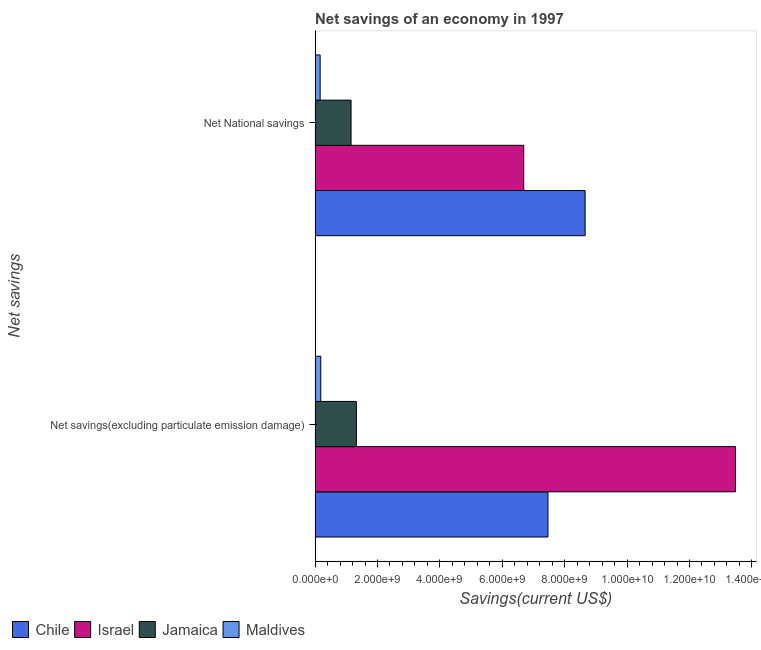How many different coloured bars are there?
Ensure brevity in your answer.  4. Are the number of bars per tick equal to the number of legend labels?
Give a very brief answer. Yes. How many bars are there on the 2nd tick from the bottom?
Offer a very short reply. 4. What is the label of the 1st group of bars from the top?
Give a very brief answer. Net National savings. What is the net savings(excluding particulate emission damage) in Maldives?
Keep it short and to the point. 1.81e+08. Across all countries, what is the maximum net national savings?
Provide a short and direct response. 8.65e+09. Across all countries, what is the minimum net national savings?
Give a very brief answer. 1.62e+08. In which country was the net savings(excluding particulate emission damage) minimum?
Offer a terse response. Maldives. What is the total net national savings in the graph?
Your answer should be compact. 1.67e+1. What is the difference between the net national savings in Jamaica and that in Israel?
Provide a succinct answer. -5.53e+09. What is the difference between the net national savings in Jamaica and the net savings(excluding particulate emission damage) in Chile?
Your response must be concise. -6.31e+09. What is the average net national savings per country?
Make the answer very short. 4.16e+09. What is the difference between the net national savings and net savings(excluding particulate emission damage) in Israel?
Offer a terse response. -6.79e+09. In how many countries, is the net national savings greater than 7600000000 US$?
Your answer should be very brief. 1. What is the ratio of the net savings(excluding particulate emission damage) in Jamaica to that in Israel?
Your answer should be very brief. 0.1. Is the net national savings in Jamaica less than that in Israel?
Your response must be concise. Yes. In how many countries, is the net savings(excluding particulate emission damage) greater than the average net savings(excluding particulate emission damage) taken over all countries?
Make the answer very short. 2. What does the 4th bar from the top in Net National savings represents?
Provide a succinct answer. Chile. How many bars are there?
Your response must be concise. 8. Are all the bars in the graph horizontal?
Your answer should be very brief. Yes. How many countries are there in the graph?
Keep it short and to the point. 4. What is the difference between two consecutive major ticks on the X-axis?
Offer a terse response. 2.00e+09. Are the values on the major ticks of X-axis written in scientific E-notation?
Your answer should be compact. Yes. Does the graph contain any zero values?
Provide a short and direct response. No. Does the graph contain grids?
Your answer should be compact. No. How many legend labels are there?
Give a very brief answer. 4. What is the title of the graph?
Your response must be concise. Net savings of an economy in 1997. What is the label or title of the X-axis?
Offer a terse response. Savings(current US$). What is the label or title of the Y-axis?
Your answer should be compact. Net savings. What is the Savings(current US$) of Chile in Net savings(excluding particulate emission damage)?
Ensure brevity in your answer.  7.46e+09. What is the Savings(current US$) in Israel in Net savings(excluding particulate emission damage)?
Make the answer very short. 1.35e+1. What is the Savings(current US$) of Jamaica in Net savings(excluding particulate emission damage)?
Make the answer very short. 1.32e+09. What is the Savings(current US$) in Maldives in Net savings(excluding particulate emission damage)?
Provide a short and direct response. 1.81e+08. What is the Savings(current US$) of Chile in Net National savings?
Provide a short and direct response. 8.65e+09. What is the Savings(current US$) in Israel in Net National savings?
Offer a terse response. 6.69e+09. What is the Savings(current US$) in Jamaica in Net National savings?
Your response must be concise. 1.15e+09. What is the Savings(current US$) in Maldives in Net National savings?
Ensure brevity in your answer.  1.62e+08. Across all Net savings, what is the maximum Savings(current US$) of Chile?
Provide a succinct answer. 8.65e+09. Across all Net savings, what is the maximum Savings(current US$) in Israel?
Make the answer very short. 1.35e+1. Across all Net savings, what is the maximum Savings(current US$) in Jamaica?
Your response must be concise. 1.32e+09. Across all Net savings, what is the maximum Savings(current US$) in Maldives?
Your response must be concise. 1.81e+08. Across all Net savings, what is the minimum Savings(current US$) in Chile?
Make the answer very short. 7.46e+09. Across all Net savings, what is the minimum Savings(current US$) in Israel?
Keep it short and to the point. 6.69e+09. Across all Net savings, what is the minimum Savings(current US$) of Jamaica?
Make the answer very short. 1.15e+09. Across all Net savings, what is the minimum Savings(current US$) in Maldives?
Your answer should be compact. 1.62e+08. What is the total Savings(current US$) of Chile in the graph?
Provide a succinct answer. 1.61e+1. What is the total Savings(current US$) of Israel in the graph?
Provide a succinct answer. 2.02e+1. What is the total Savings(current US$) of Jamaica in the graph?
Give a very brief answer. 2.47e+09. What is the total Savings(current US$) of Maldives in the graph?
Your answer should be compact. 3.43e+08. What is the difference between the Savings(current US$) in Chile in Net savings(excluding particulate emission damage) and that in Net National savings?
Offer a very short reply. -1.19e+09. What is the difference between the Savings(current US$) in Israel in Net savings(excluding particulate emission damage) and that in Net National savings?
Give a very brief answer. 6.79e+09. What is the difference between the Savings(current US$) of Jamaica in Net savings(excluding particulate emission damage) and that in Net National savings?
Ensure brevity in your answer.  1.70e+08. What is the difference between the Savings(current US$) in Maldives in Net savings(excluding particulate emission damage) and that in Net National savings?
Your response must be concise. 1.97e+07. What is the difference between the Savings(current US$) of Chile in Net savings(excluding particulate emission damage) and the Savings(current US$) of Israel in Net National savings?
Offer a terse response. 7.76e+08. What is the difference between the Savings(current US$) of Chile in Net savings(excluding particulate emission damage) and the Savings(current US$) of Jamaica in Net National savings?
Your answer should be compact. 6.31e+09. What is the difference between the Savings(current US$) of Chile in Net savings(excluding particulate emission damage) and the Savings(current US$) of Maldives in Net National savings?
Your answer should be very brief. 7.30e+09. What is the difference between the Savings(current US$) of Israel in Net savings(excluding particulate emission damage) and the Savings(current US$) of Jamaica in Net National savings?
Keep it short and to the point. 1.23e+1. What is the difference between the Savings(current US$) of Israel in Net savings(excluding particulate emission damage) and the Savings(current US$) of Maldives in Net National savings?
Your answer should be very brief. 1.33e+1. What is the difference between the Savings(current US$) of Jamaica in Net savings(excluding particulate emission damage) and the Savings(current US$) of Maldives in Net National savings?
Provide a succinct answer. 1.16e+09. What is the average Savings(current US$) of Chile per Net savings?
Make the answer very short. 8.06e+09. What is the average Savings(current US$) in Israel per Net savings?
Provide a succinct answer. 1.01e+1. What is the average Savings(current US$) in Jamaica per Net savings?
Offer a very short reply. 1.24e+09. What is the average Savings(current US$) of Maldives per Net savings?
Offer a terse response. 1.72e+08. What is the difference between the Savings(current US$) in Chile and Savings(current US$) in Israel in Net savings(excluding particulate emission damage)?
Your answer should be very brief. -6.01e+09. What is the difference between the Savings(current US$) in Chile and Savings(current US$) in Jamaica in Net savings(excluding particulate emission damage)?
Keep it short and to the point. 6.14e+09. What is the difference between the Savings(current US$) of Chile and Savings(current US$) of Maldives in Net savings(excluding particulate emission damage)?
Keep it short and to the point. 7.28e+09. What is the difference between the Savings(current US$) of Israel and Savings(current US$) of Jamaica in Net savings(excluding particulate emission damage)?
Give a very brief answer. 1.22e+1. What is the difference between the Savings(current US$) in Israel and Savings(current US$) in Maldives in Net savings(excluding particulate emission damage)?
Your answer should be compact. 1.33e+1. What is the difference between the Savings(current US$) of Jamaica and Savings(current US$) of Maldives in Net savings(excluding particulate emission damage)?
Make the answer very short. 1.14e+09. What is the difference between the Savings(current US$) in Chile and Savings(current US$) in Israel in Net National savings?
Make the answer very short. 1.97e+09. What is the difference between the Savings(current US$) of Chile and Savings(current US$) of Jamaica in Net National savings?
Your answer should be very brief. 7.50e+09. What is the difference between the Savings(current US$) in Chile and Savings(current US$) in Maldives in Net National savings?
Your response must be concise. 8.49e+09. What is the difference between the Savings(current US$) in Israel and Savings(current US$) in Jamaica in Net National savings?
Keep it short and to the point. 5.53e+09. What is the difference between the Savings(current US$) in Israel and Savings(current US$) in Maldives in Net National savings?
Keep it short and to the point. 6.53e+09. What is the difference between the Savings(current US$) of Jamaica and Savings(current US$) of Maldives in Net National savings?
Ensure brevity in your answer.  9.91e+08. What is the ratio of the Savings(current US$) in Chile in Net savings(excluding particulate emission damage) to that in Net National savings?
Provide a succinct answer. 0.86. What is the ratio of the Savings(current US$) of Israel in Net savings(excluding particulate emission damage) to that in Net National savings?
Make the answer very short. 2.01. What is the ratio of the Savings(current US$) in Jamaica in Net savings(excluding particulate emission damage) to that in Net National savings?
Keep it short and to the point. 1.15. What is the ratio of the Savings(current US$) in Maldives in Net savings(excluding particulate emission damage) to that in Net National savings?
Keep it short and to the point. 1.12. What is the difference between the highest and the second highest Savings(current US$) of Chile?
Offer a very short reply. 1.19e+09. What is the difference between the highest and the second highest Savings(current US$) in Israel?
Make the answer very short. 6.79e+09. What is the difference between the highest and the second highest Savings(current US$) of Jamaica?
Your answer should be very brief. 1.70e+08. What is the difference between the highest and the second highest Savings(current US$) of Maldives?
Provide a succinct answer. 1.97e+07. What is the difference between the highest and the lowest Savings(current US$) of Chile?
Provide a short and direct response. 1.19e+09. What is the difference between the highest and the lowest Savings(current US$) of Israel?
Offer a very short reply. 6.79e+09. What is the difference between the highest and the lowest Savings(current US$) of Jamaica?
Offer a very short reply. 1.70e+08. What is the difference between the highest and the lowest Savings(current US$) in Maldives?
Your response must be concise. 1.97e+07. 